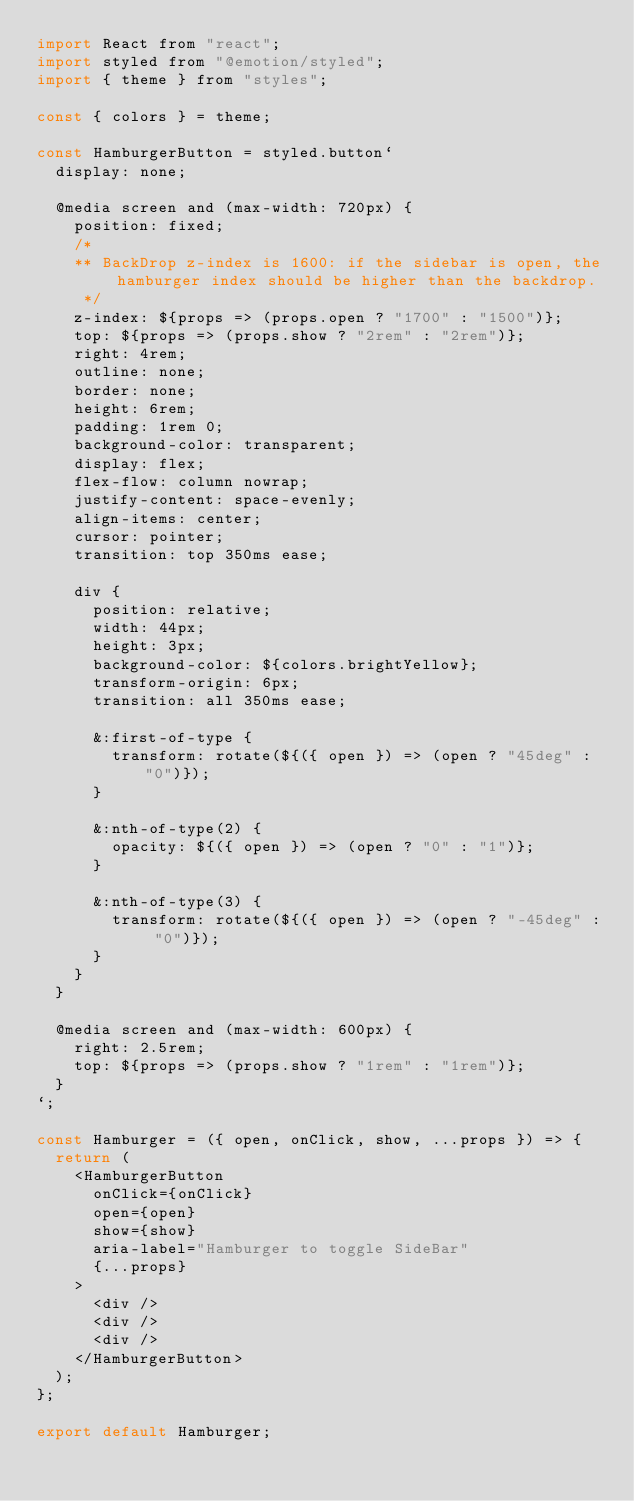<code> <loc_0><loc_0><loc_500><loc_500><_JavaScript_>import React from "react";
import styled from "@emotion/styled";
import { theme } from "styles";

const { colors } = theme;

const HamburgerButton = styled.button`
  display: none;

  @media screen and (max-width: 720px) {
    position: fixed;
    /*
    ** BackDrop z-index is 1600: if the sidebar is open, the hamburger index should be higher than the backdrop.
     */
    z-index: ${props => (props.open ? "1700" : "1500")};
    top: ${props => (props.show ? "2rem" : "2rem")};
    right: 4rem;
    outline: none;
    border: none;
    height: 6rem;
    padding: 1rem 0;
    background-color: transparent;
    display: flex;
    flex-flow: column nowrap;
    justify-content: space-evenly;
    align-items: center;
    cursor: pointer;
    transition: top 350ms ease;

    div {
      position: relative;
      width: 44px;
      height: 3px;
      background-color: ${colors.brightYellow};
      transform-origin: 6px;
      transition: all 350ms ease;

      &:first-of-type {
        transform: rotate(${({ open }) => (open ? "45deg" : "0")});
      }

      &:nth-of-type(2) {
        opacity: ${({ open }) => (open ? "0" : "1")};
      }

      &:nth-of-type(3) {
        transform: rotate(${({ open }) => (open ? "-45deg" : "0")});
      }
    }
  }

  @media screen and (max-width: 600px) {
    right: 2.5rem;
    top: ${props => (props.show ? "1rem" : "1rem")};
  }
`;

const Hamburger = ({ open, onClick, show, ...props }) => {
  return (
    <HamburgerButton
      onClick={onClick}
      open={open}
      show={show}
      aria-label="Hamburger to toggle SideBar"
      {...props}
    >
      <div />
      <div />
      <div />
    </HamburgerButton>
  );
};

export default Hamburger;
</code> 